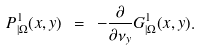<formula> <loc_0><loc_0><loc_500><loc_500>P _ { | \Omega } ^ { 1 } ( x , y ) \ = \ - \frac { \partial } { \partial \nu _ { y } } G ^ { 1 } _ { | \Omega } ( x , y ) .</formula> 